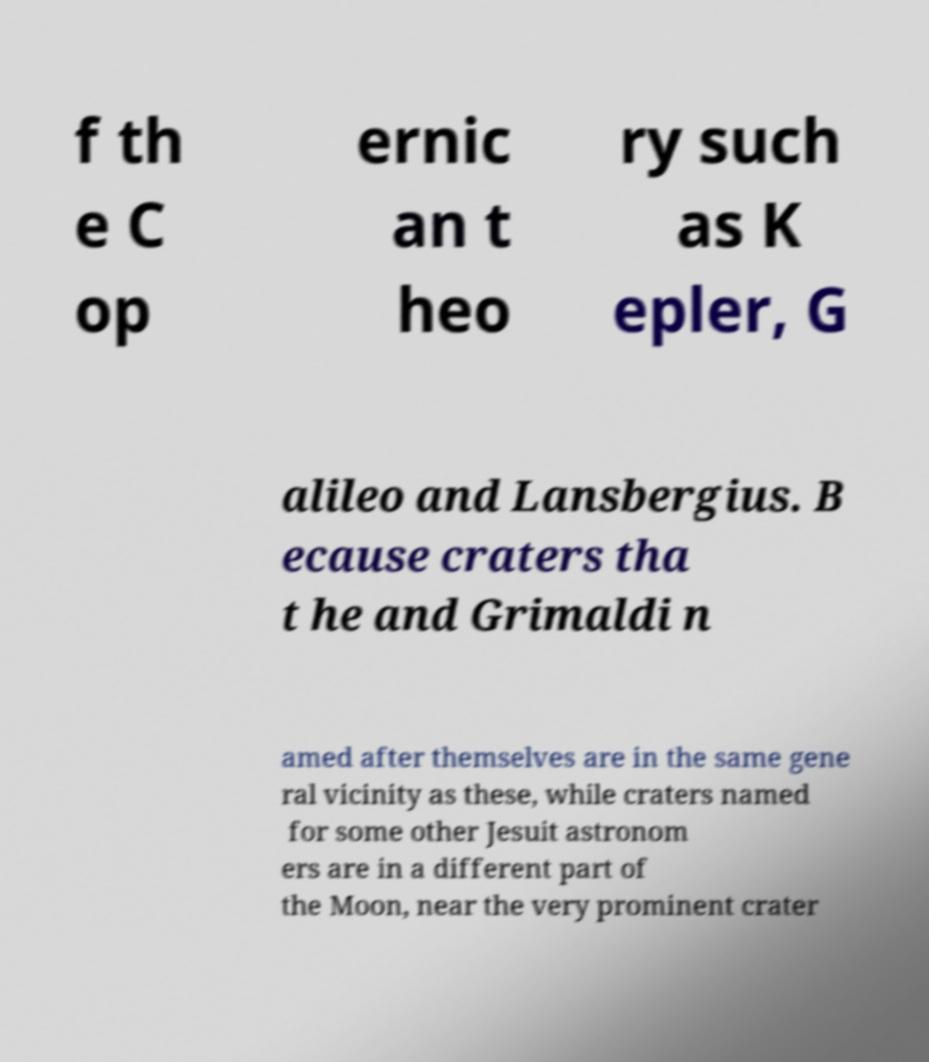Could you assist in decoding the text presented in this image and type it out clearly? f th e C op ernic an t heo ry such as K epler, G alileo and Lansbergius. B ecause craters tha t he and Grimaldi n amed after themselves are in the same gene ral vicinity as these, while craters named for some other Jesuit astronom ers are in a different part of the Moon, near the very prominent crater 